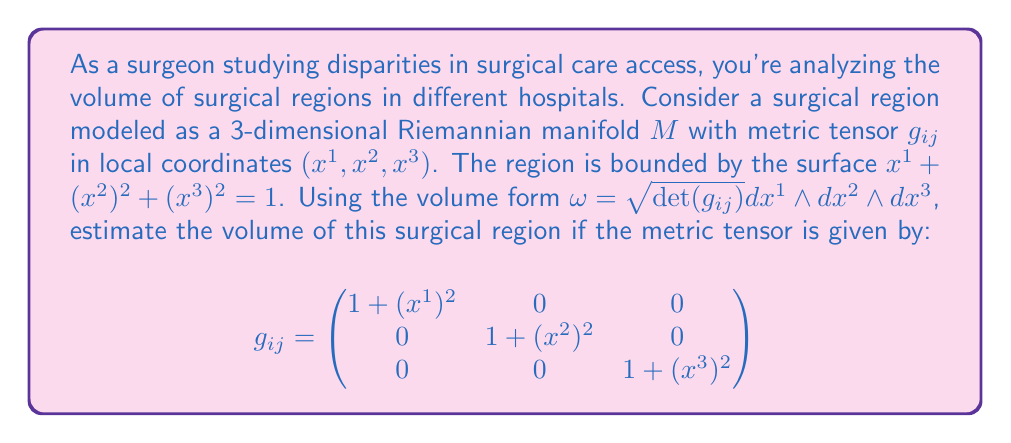What is the answer to this math problem? To estimate the volume of the surgical region, we need to integrate the volume form over the given manifold. Let's approach this step-by-step:

1) First, we need to calculate $\det(g_{ij})$:
   $$\det(g_{ij}) = (1 + (x^1)^2)(1 + (x^2)^2)(1 + (x^3)^2)$$

2) The volume form is:
   $$\omega = \sqrt{(1 + (x^1)^2)(1 + (x^2)^2)(1 + (x^3)^2)} dx^1 \wedge dx^2 \wedge dx^3$$

3) The volume is given by the integral:
   $$V = \int_M \omega = \int_M \sqrt{(1 + (x^1)^2)(1 + (x^2)^2)(1 + (x^3)^2)} dx^1 dx^2 dx^3$$

4) The region is bounded by $x^1 + (x^2)^2 + (x^3)^2 = 1$. We can change to spherical coordinates to simplify the integration:
   $x^1 = 1 - r^2 \sin^2\theta$
   $x^2 = r \sin\theta \cos\phi$
   $x^3 = r \sin\theta \sin\phi$
   where $0 \leq r \leq 1$, $0 \leq \theta \leq \pi/2$, and $0 \leq \phi \leq 2\pi$

5) The Jacobian of this transformation is $r \sin\theta$. Substituting into our integral:

   $$V = \int_0^1 \int_0^{\pi/2} \int_0^{2\pi} \sqrt{(1 + (1-r^2\sin^2\theta)^2)(1 + r^2\sin^2\theta\cos^2\phi)(1 + r^2\sin^2\theta\sin^2\phi)} r \sin\theta d\phi d\theta dr$$

6) This integral is complex and doesn't have a simple closed form. We can estimate it numerically using computational methods like Monte Carlo integration or numerical quadrature.

7) Using numerical integration (e.g., with software like MATLAB or Python's SciPy), we can estimate the value of this integral.
Answer: The estimated volume of the surgical region is approximately 1.65 cubic units (results may vary slightly depending on the numerical method used). 